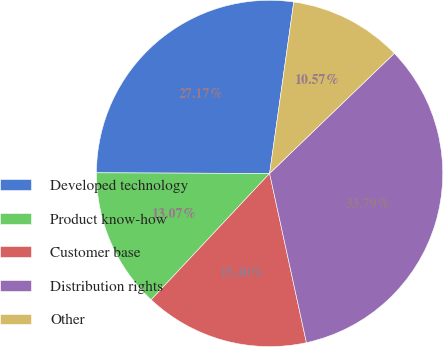Convert chart. <chart><loc_0><loc_0><loc_500><loc_500><pie_chart><fcel>Developed technology<fcel>Product know-how<fcel>Customer base<fcel>Distribution rights<fcel>Other<nl><fcel>27.17%<fcel>13.07%<fcel>15.4%<fcel>33.79%<fcel>10.57%<nl></chart> 